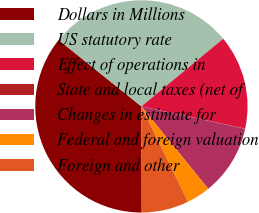Convert chart to OTSL. <chart><loc_0><loc_0><loc_500><loc_500><pie_chart><fcel>Dollars in Millions<fcel>US statutory rate<fcel>Effect of operations in<fcel>State and local taxes (net of<fcel>Changes in estimate for<fcel>Federal and foreign valuation<fcel>Foreign and other<nl><fcel>35.81%<fcel>28.24%<fcel>14.35%<fcel>0.04%<fcel>10.77%<fcel>3.61%<fcel>7.19%<nl></chart> 